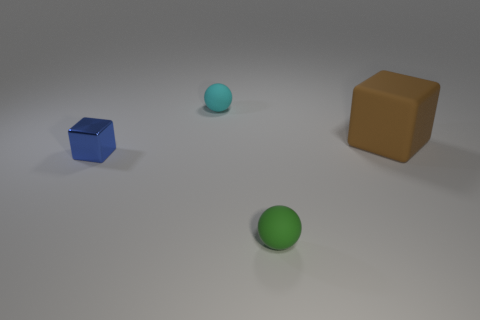Is there anything else of the same color as the metallic cube?
Offer a terse response. No. What number of things are large purple things or small matte spheres?
Offer a very short reply. 2. There is a green rubber sphere that is on the right side of the cyan matte ball; is its size the same as the big brown matte object?
Offer a terse response. No. What number of other things are the same size as the blue metallic thing?
Your answer should be very brief. 2. Are there any tiny cyan matte things?
Your answer should be very brief. Yes. There is a sphere that is behind the brown thing behind the small blue block; how big is it?
Make the answer very short. Small. There is a small object that is behind the rubber cube; does it have the same color as the matte thing that is to the right of the small green sphere?
Provide a short and direct response. No. There is a object that is in front of the big brown object and to the right of the shiny cube; what color is it?
Your response must be concise. Green. How many other things are the same shape as the big thing?
Offer a very short reply. 1. The metallic cube that is the same size as the cyan object is what color?
Offer a terse response. Blue. 